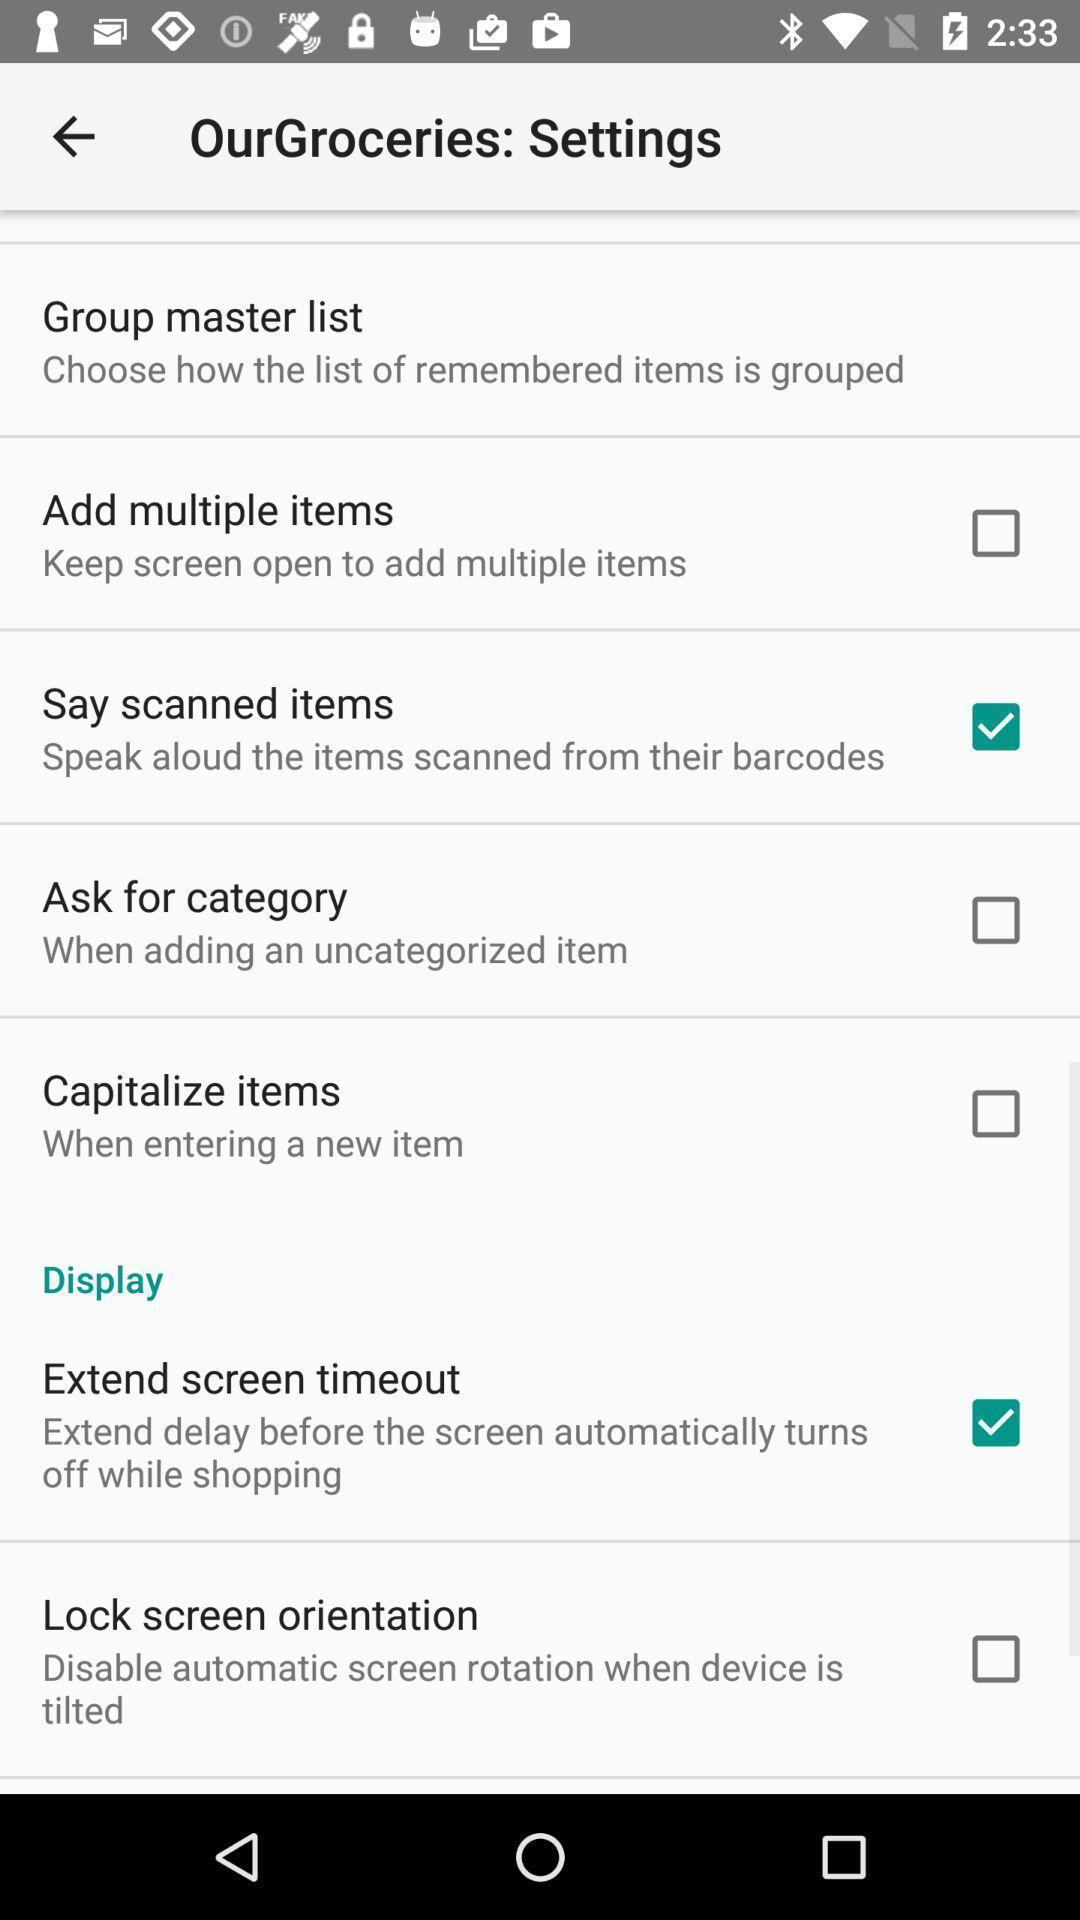Give me a summary of this screen capture. Settings page of groceries app. 